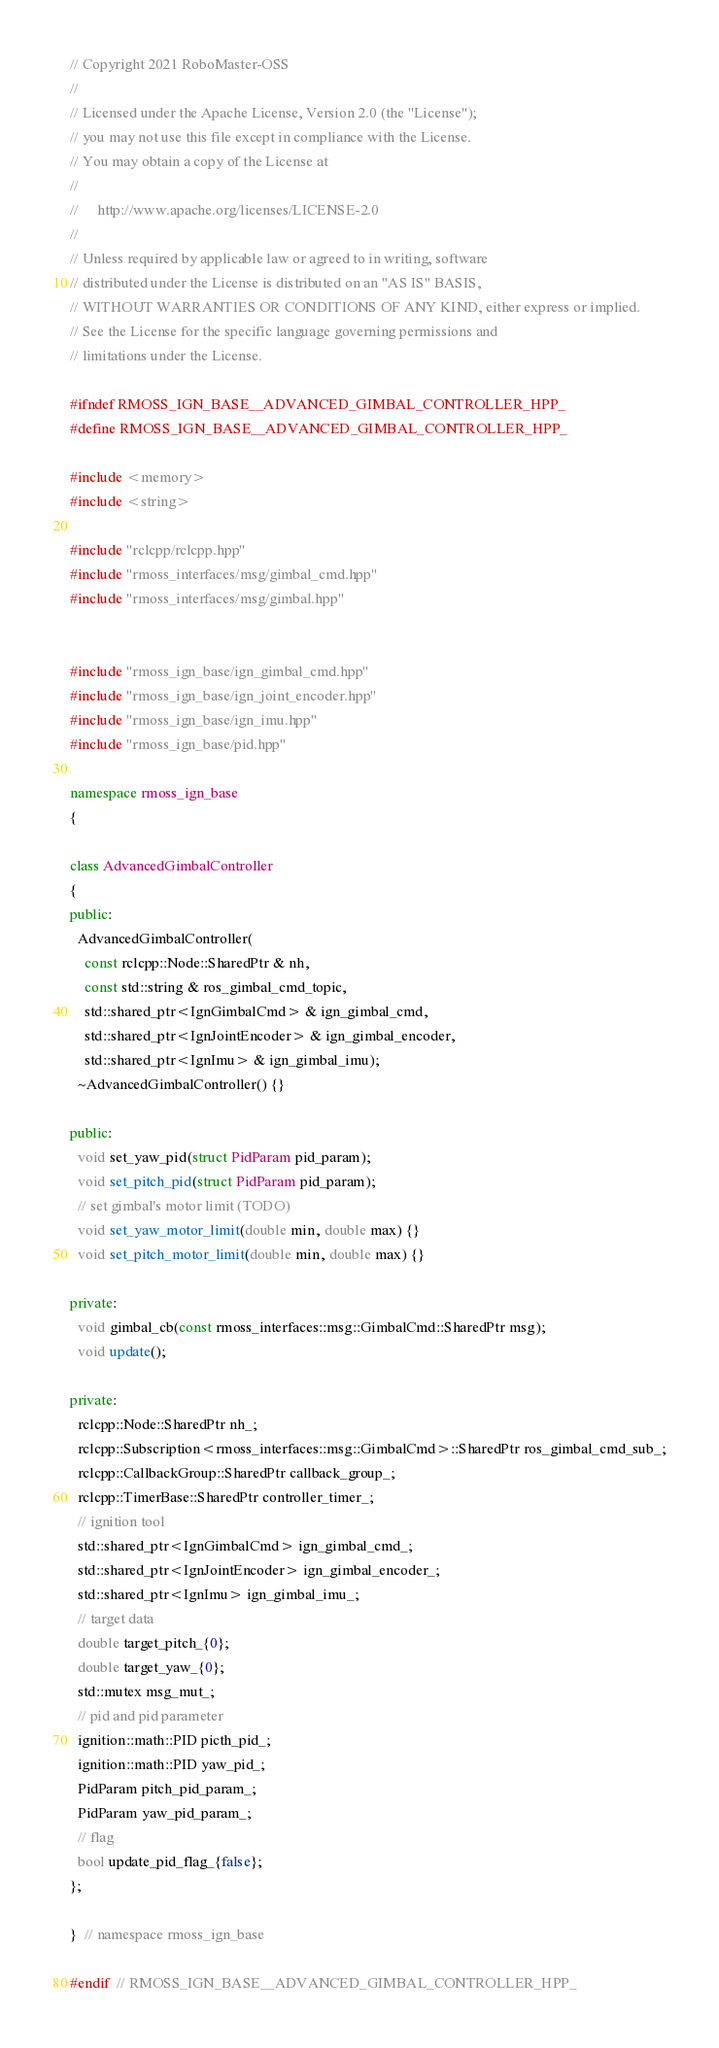Convert code to text. <code><loc_0><loc_0><loc_500><loc_500><_C++_>// Copyright 2021 RoboMaster-OSS
//
// Licensed under the Apache License, Version 2.0 (the "License");
// you may not use this file except in compliance with the License.
// You may obtain a copy of the License at
//
//     http://www.apache.org/licenses/LICENSE-2.0
//
// Unless required by applicable law or agreed to in writing, software
// distributed under the License is distributed on an "AS IS" BASIS,
// WITHOUT WARRANTIES OR CONDITIONS OF ANY KIND, either express or implied.
// See the License for the specific language governing permissions and
// limitations under the License.

#ifndef RMOSS_IGN_BASE__ADVANCED_GIMBAL_CONTROLLER_HPP_
#define RMOSS_IGN_BASE__ADVANCED_GIMBAL_CONTROLLER_HPP_

#include <memory>
#include <string>

#include "rclcpp/rclcpp.hpp"
#include "rmoss_interfaces/msg/gimbal_cmd.hpp"
#include "rmoss_interfaces/msg/gimbal.hpp"


#include "rmoss_ign_base/ign_gimbal_cmd.hpp"
#include "rmoss_ign_base/ign_joint_encoder.hpp"
#include "rmoss_ign_base/ign_imu.hpp"
#include "rmoss_ign_base/pid.hpp"

namespace rmoss_ign_base
{

class AdvancedGimbalController
{
public:
  AdvancedGimbalController(
    const rclcpp::Node::SharedPtr & nh,
    const std::string & ros_gimbal_cmd_topic,
    std::shared_ptr<IgnGimbalCmd> & ign_gimbal_cmd,
    std::shared_ptr<IgnJointEncoder> & ign_gimbal_encoder,
    std::shared_ptr<IgnImu> & ign_gimbal_imu);
  ~AdvancedGimbalController() {}

public:
  void set_yaw_pid(struct PidParam pid_param);
  void set_pitch_pid(struct PidParam pid_param);
  // set gimbal's motor limit (TODO)
  void set_yaw_motor_limit(double min, double max) {}
  void set_pitch_motor_limit(double min, double max) {}

private:
  void gimbal_cb(const rmoss_interfaces::msg::GimbalCmd::SharedPtr msg);
  void update();

private:
  rclcpp::Node::SharedPtr nh_;
  rclcpp::Subscription<rmoss_interfaces::msg::GimbalCmd>::SharedPtr ros_gimbal_cmd_sub_;
  rclcpp::CallbackGroup::SharedPtr callback_group_;
  rclcpp::TimerBase::SharedPtr controller_timer_;
  // ignition tool
  std::shared_ptr<IgnGimbalCmd> ign_gimbal_cmd_;
  std::shared_ptr<IgnJointEncoder> ign_gimbal_encoder_;
  std::shared_ptr<IgnImu> ign_gimbal_imu_;
  // target data
  double target_pitch_{0};
  double target_yaw_{0};
  std::mutex msg_mut_;
  // pid and pid parameter
  ignition::math::PID picth_pid_;
  ignition::math::PID yaw_pid_;
  PidParam pitch_pid_param_;
  PidParam yaw_pid_param_;
  // flag
  bool update_pid_flag_{false};
};

}  // namespace rmoss_ign_base

#endif  // RMOSS_IGN_BASE__ADVANCED_GIMBAL_CONTROLLER_HPP_
</code> 